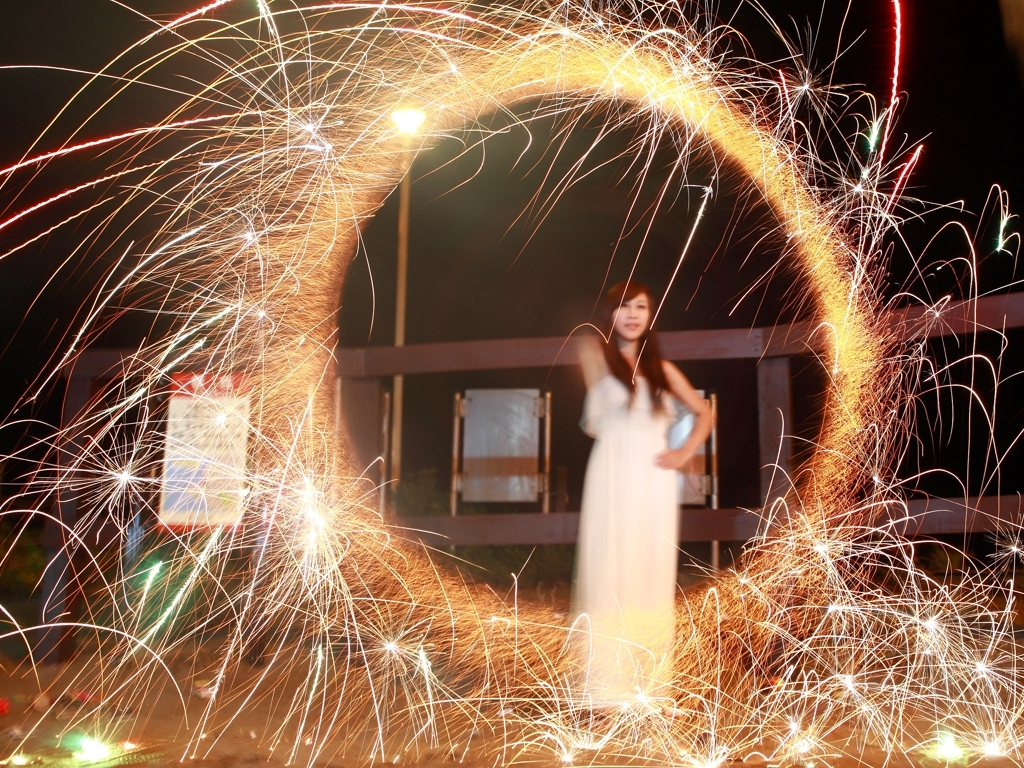Can you suggest how the photo might be improved? To improve the photo, stabilizing the camera on a tripod would help in avoiding blurriness of static subjects like the person standing. Additionally, adjusting the focus or using a faster shutter speed could keep the person sharp against the backdrop of light trails, enhancing the contrast between movement and stillness. 